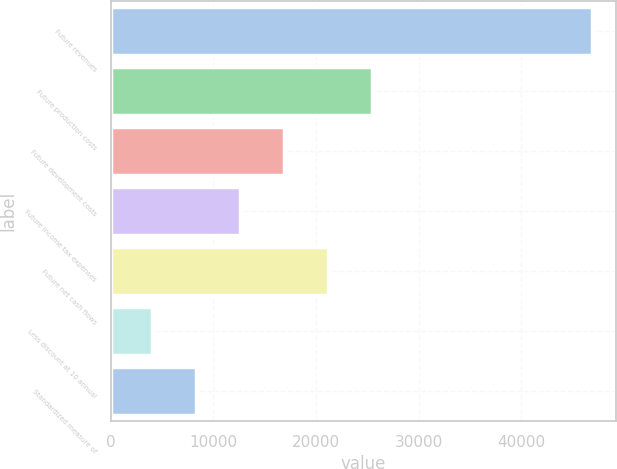Convert chart to OTSL. <chart><loc_0><loc_0><loc_500><loc_500><bar_chart><fcel>Future revenues<fcel>Future production costs<fcel>Future development costs<fcel>Future income tax expenses<fcel>Future net cash flows<fcel>Less discount at 10 annual<fcel>Standardized measure of<nl><fcel>46846<fcel>25448<fcel>16888.8<fcel>12609.2<fcel>21168.4<fcel>4050<fcel>8329.6<nl></chart> 